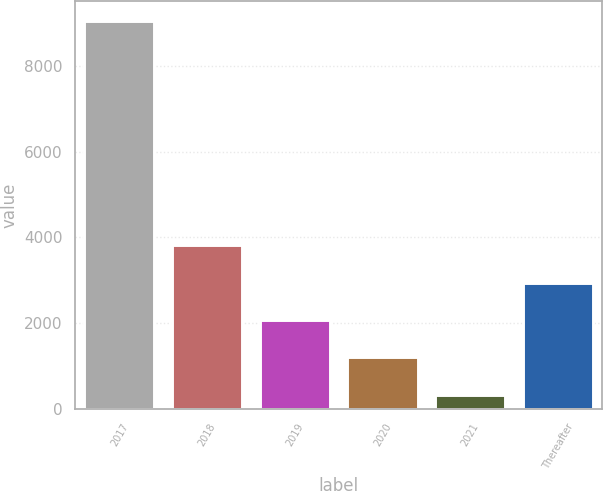<chart> <loc_0><loc_0><loc_500><loc_500><bar_chart><fcel>2017<fcel>2018<fcel>2019<fcel>2020<fcel>2021<fcel>Thereafter<nl><fcel>9065<fcel>3822.2<fcel>2074.6<fcel>1200.8<fcel>327<fcel>2948.4<nl></chart> 